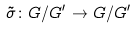<formula> <loc_0><loc_0><loc_500><loc_500>\tilde { \sigma } \colon G / G ^ { \prime } \rightarrow G / G ^ { \prime }</formula> 